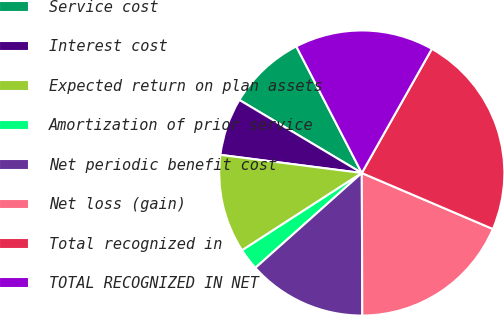Convert chart. <chart><loc_0><loc_0><loc_500><loc_500><pie_chart><fcel>Service cost<fcel>Interest cost<fcel>Expected return on plan assets<fcel>Amortization of prior service<fcel>Net periodic benefit cost<fcel>Net loss (gain)<fcel>Total recognized in<fcel>TOTAL RECOGNIZED IN NET<nl><fcel>8.84%<fcel>6.53%<fcel>11.16%<fcel>2.46%<fcel>13.47%<fcel>18.52%<fcel>23.25%<fcel>15.78%<nl></chart> 